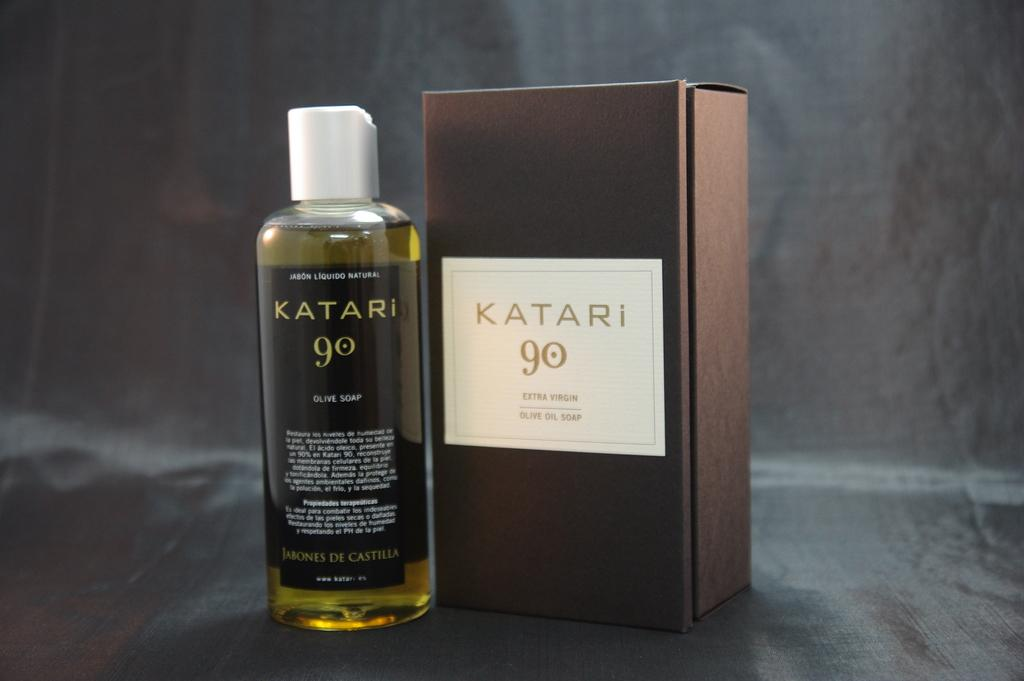<image>
Offer a succinct explanation of the picture presented. Large brown box of Katari 90 next to a bottle of Katari 90. 